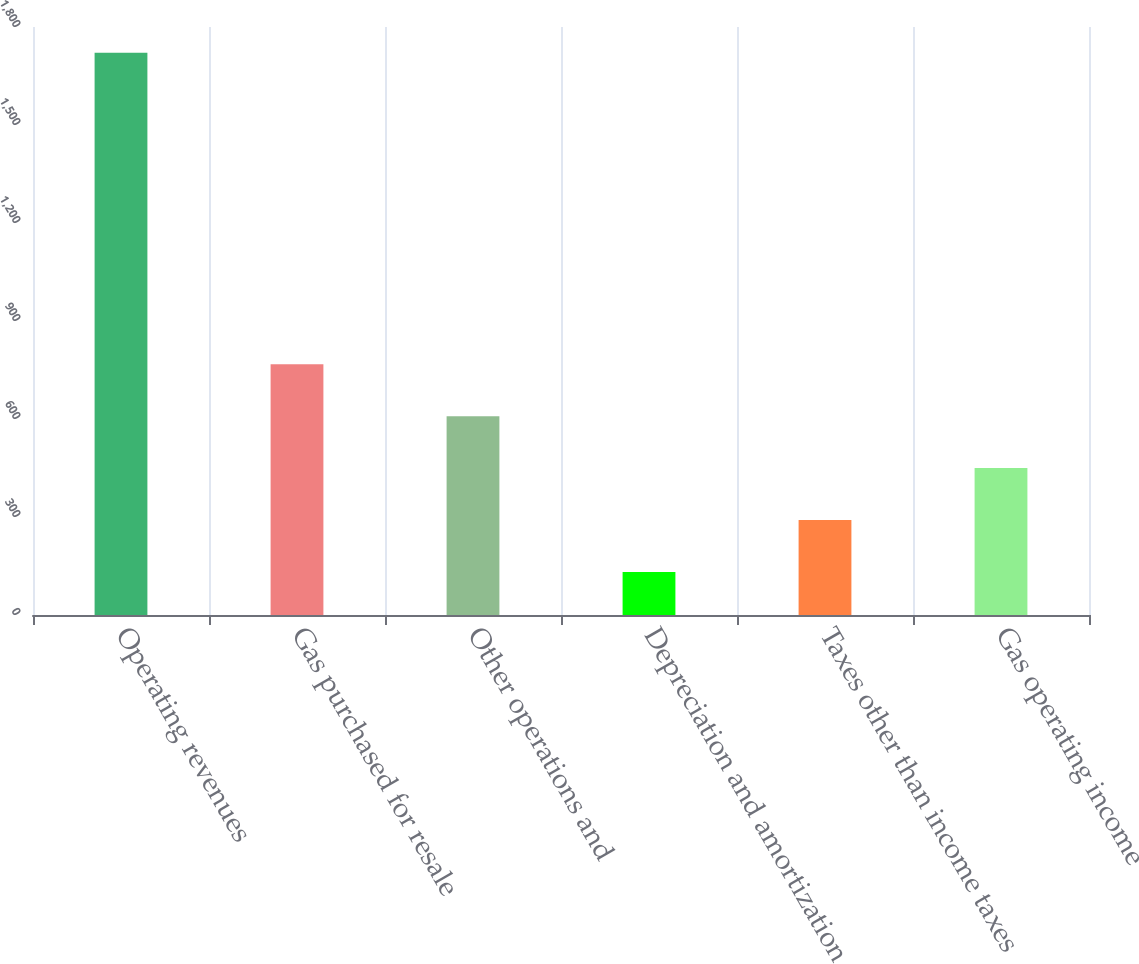Convert chart. <chart><loc_0><loc_0><loc_500><loc_500><bar_chart><fcel>Operating revenues<fcel>Gas purchased for resale<fcel>Other operations and<fcel>Depreciation and amortization<fcel>Taxes other than income taxes<fcel>Gas operating income<nl><fcel>1721<fcel>767.6<fcel>608.7<fcel>132<fcel>290.9<fcel>449.8<nl></chart> 